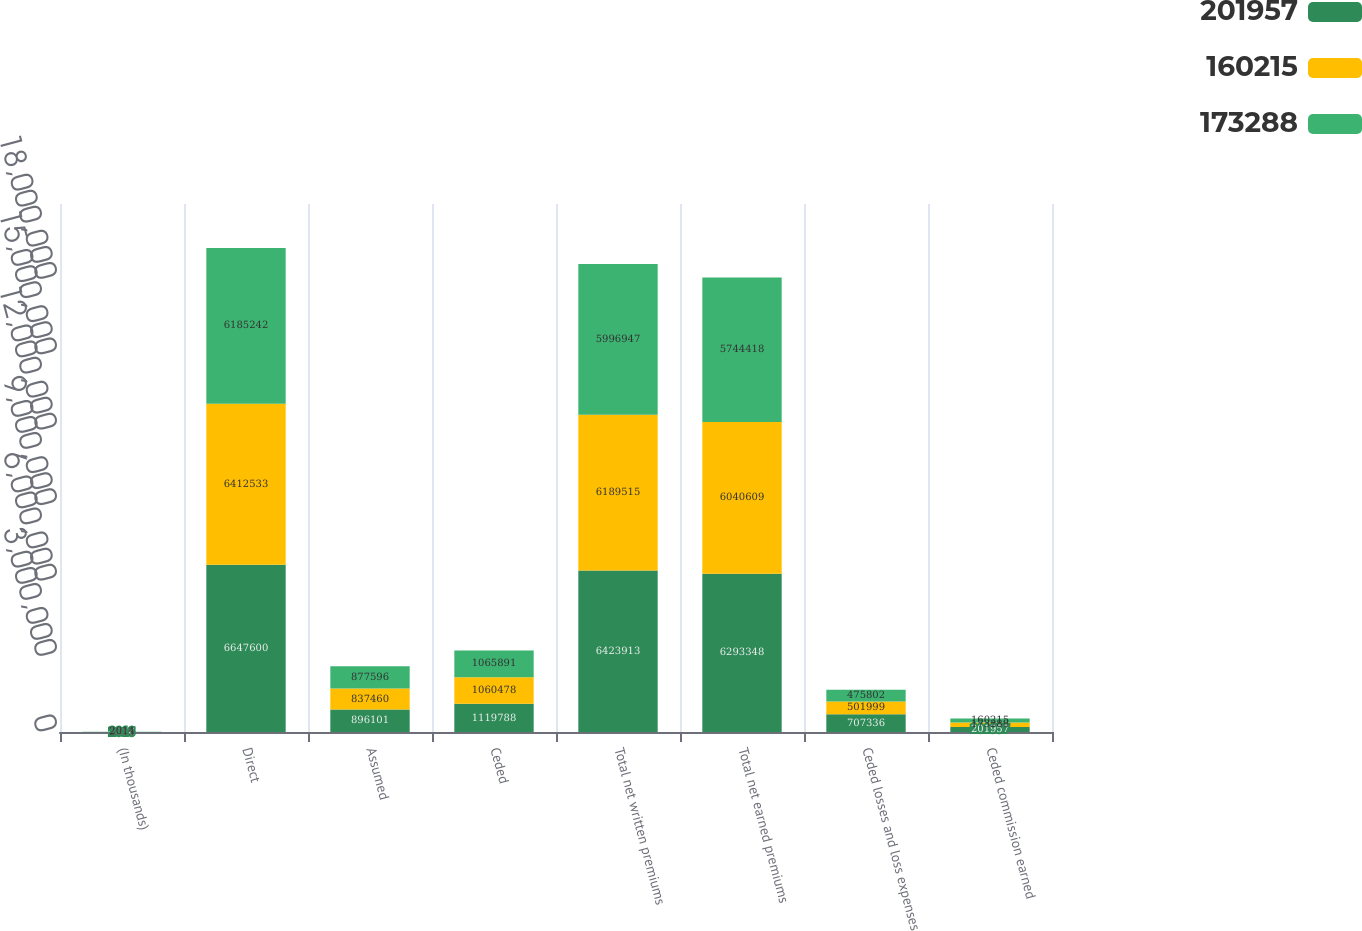Convert chart to OTSL. <chart><loc_0><loc_0><loc_500><loc_500><stacked_bar_chart><ecel><fcel>(In thousands)<fcel>Direct<fcel>Assumed<fcel>Ceded<fcel>Total net written premiums<fcel>Total net earned premiums<fcel>Ceded losses and loss expenses<fcel>Ceded commission earned<nl><fcel>201957<fcel>2016<fcel>6.6476e+06<fcel>896101<fcel>1.11979e+06<fcel>6.42391e+06<fcel>6.29335e+06<fcel>707336<fcel>201957<nl><fcel>160215<fcel>2015<fcel>6.41253e+06<fcel>837460<fcel>1.06048e+06<fcel>6.18952e+06<fcel>6.04061e+06<fcel>501999<fcel>173288<nl><fcel>173288<fcel>2014<fcel>6.18524e+06<fcel>877596<fcel>1.06589e+06<fcel>5.99695e+06<fcel>5.74442e+06<fcel>475802<fcel>160215<nl></chart> 